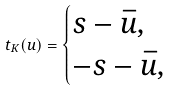Convert formula to latex. <formula><loc_0><loc_0><loc_500><loc_500>t _ { K } ( u ) = \begin{cases} s - \bar { u } , \\ - s - \bar { u } , \end{cases}</formula> 